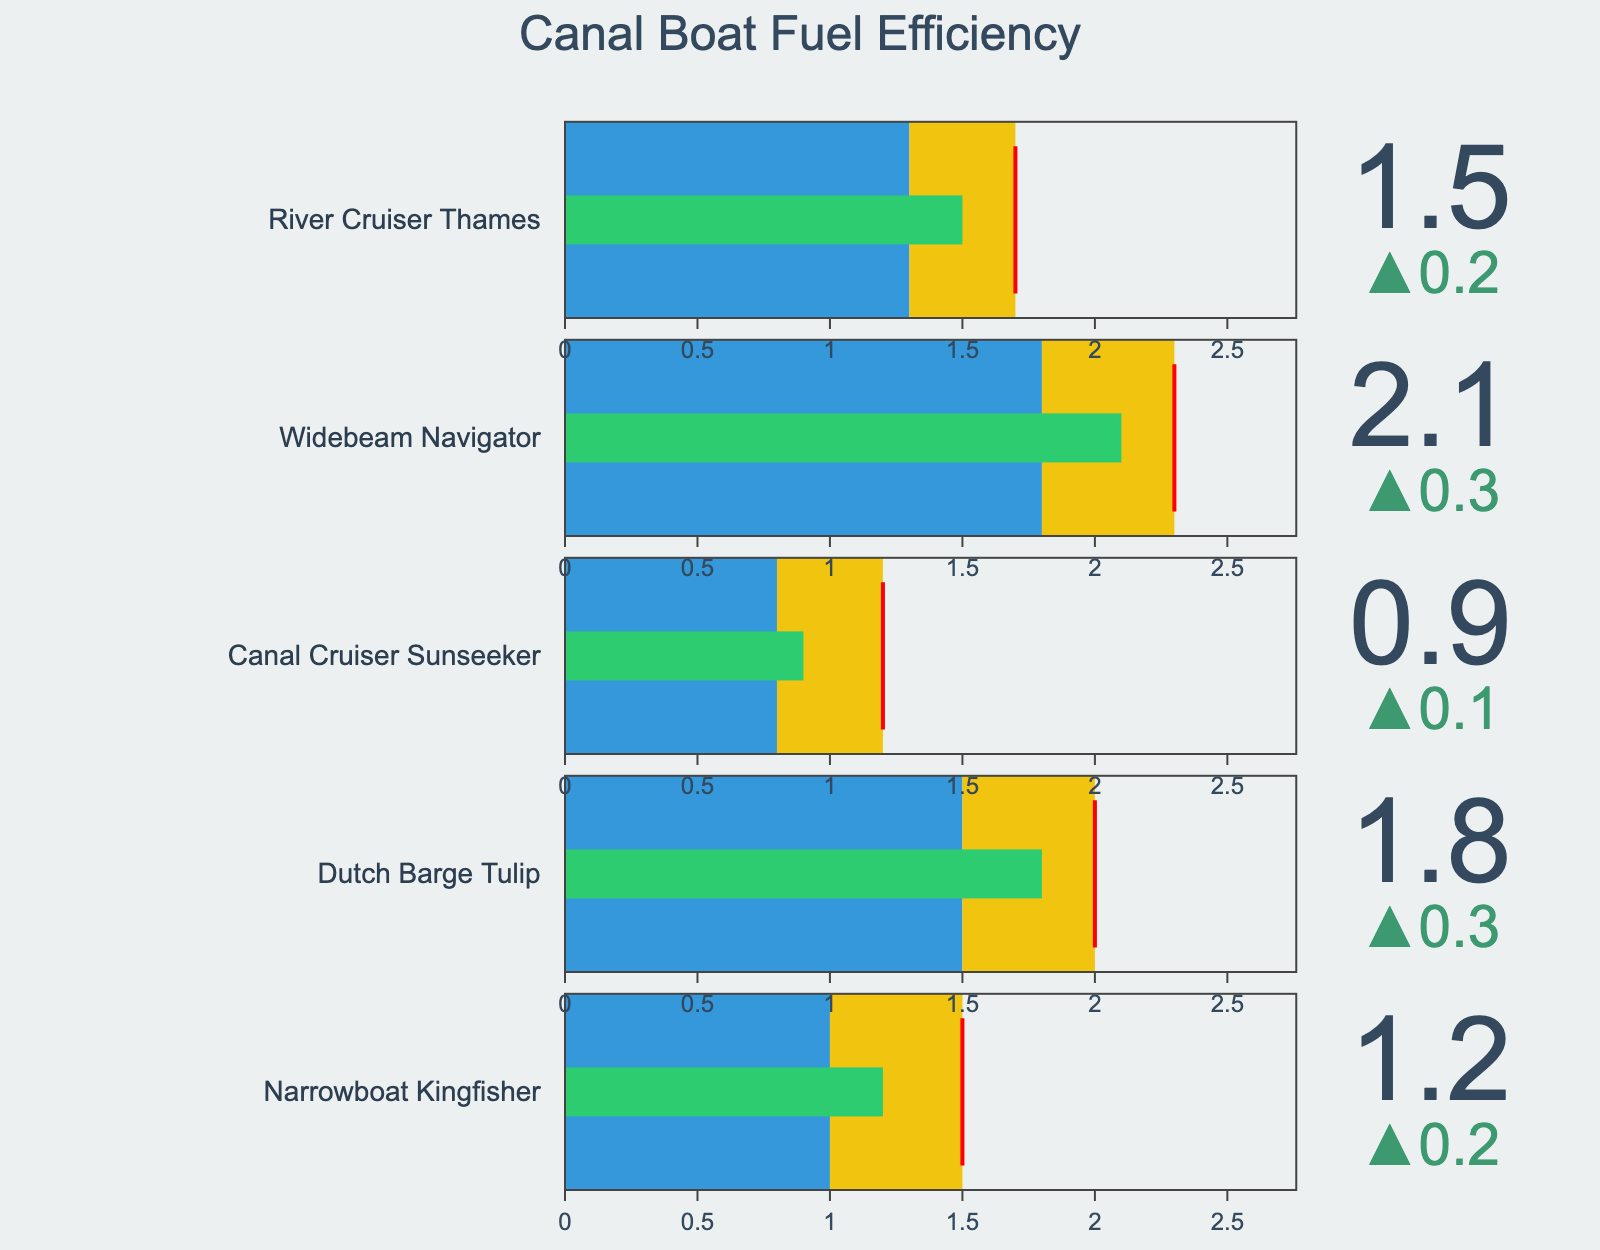what's the title of the figure? The title is displayed at the top of the Bullet Chart and summarizes the main subject of the chart.
Answer: Canal Boat Fuel Efficiency how many boat models are shown in the figure? To determine the number of boat models, count the distinct titles representing each boat in the chart.
Answer: 5 what color represents the target efficiency range in the figure? Look at the color of the bar section that represents target efficiency on the Bullet Chart.
Answer: Blue which boat model has the highest actual efficiency (l/km)? Locate the values for each boat model, compare them to find the one with the highest value.
Answer: Widebeam Navigator is the Narrowboat Kingfisher's actual efficiency better or worse than the industry average? Compare the Actual Efficiency value for Narrowboat Kingfisher with the Industry Average value. Since 1.2 is less than 1.5, it is better.
Answer: Better which boat model has the smallest difference between the actual and target efficiency (l/km)? Calculate the differences between actual and target efficiencies for all boat models, then determine the smallest difference.
Answer: Canal Cruiser Sunseeker compare the actual efficiency of the Dutch Barge Tulip and River Cruiser Thames. Which one is more fuel-efficient? Compare the Actual Efficiency values for Dutch Barge Tulip (1.8 l/km) and River Cruiser Thames (1.5 l/km). The boat with the lower value is more efficient.
Answer: River Cruiser Thames if the industry average efficiency target is to be reduced by 10%, what would the new threshold be for the Widebeam Navigator? Compute 10% of the Industry Average for Widebeam Navigator (2.3 l/km) and subtract this value from the original average. 10% of 2.3 is 0.23, so 2.3 - 0.23 = 2.07 l/km.
Answer: 2.07 l/km which boat models have an actual efficiency that is within the target range? Identify the boat models whose actual efficiencies fall within their respective target ranges. Models where the actual value is less than or equal to the target value.
Answer: Canal Cruiser Sunseeker 